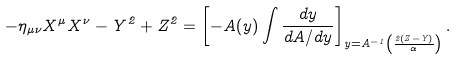Convert formula to latex. <formula><loc_0><loc_0><loc_500><loc_500>- \eta _ { \mu \nu } X ^ { \mu } X ^ { \nu } - Y ^ { 2 } + Z ^ { 2 } = \left [ - A ( y ) \int \frac { d y } { d A / d y } \right ] _ { y = A ^ { - 1 } \left ( \frac { 2 ( Z - Y ) } { \alpha } \right ) } .</formula> 